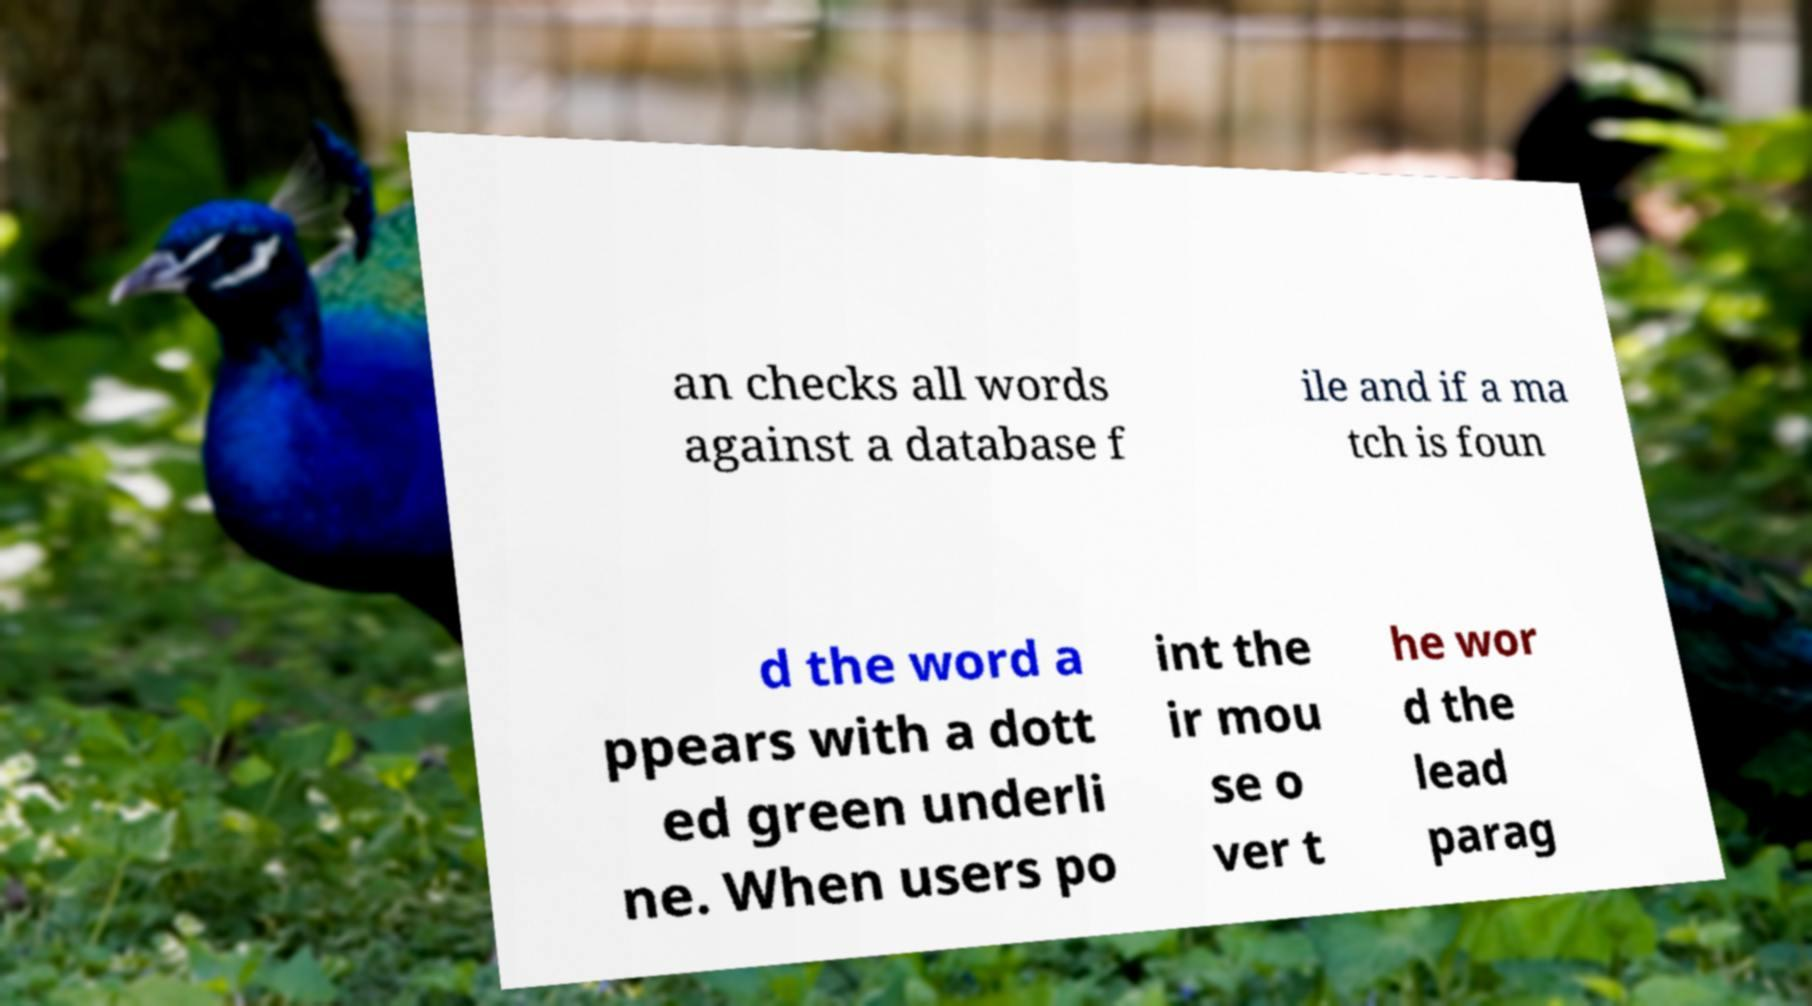Can you accurately transcribe the text from the provided image for me? an checks all words against a database f ile and if a ma tch is foun d the word a ppears with a dott ed green underli ne. When users po int the ir mou se o ver t he wor d the lead parag 